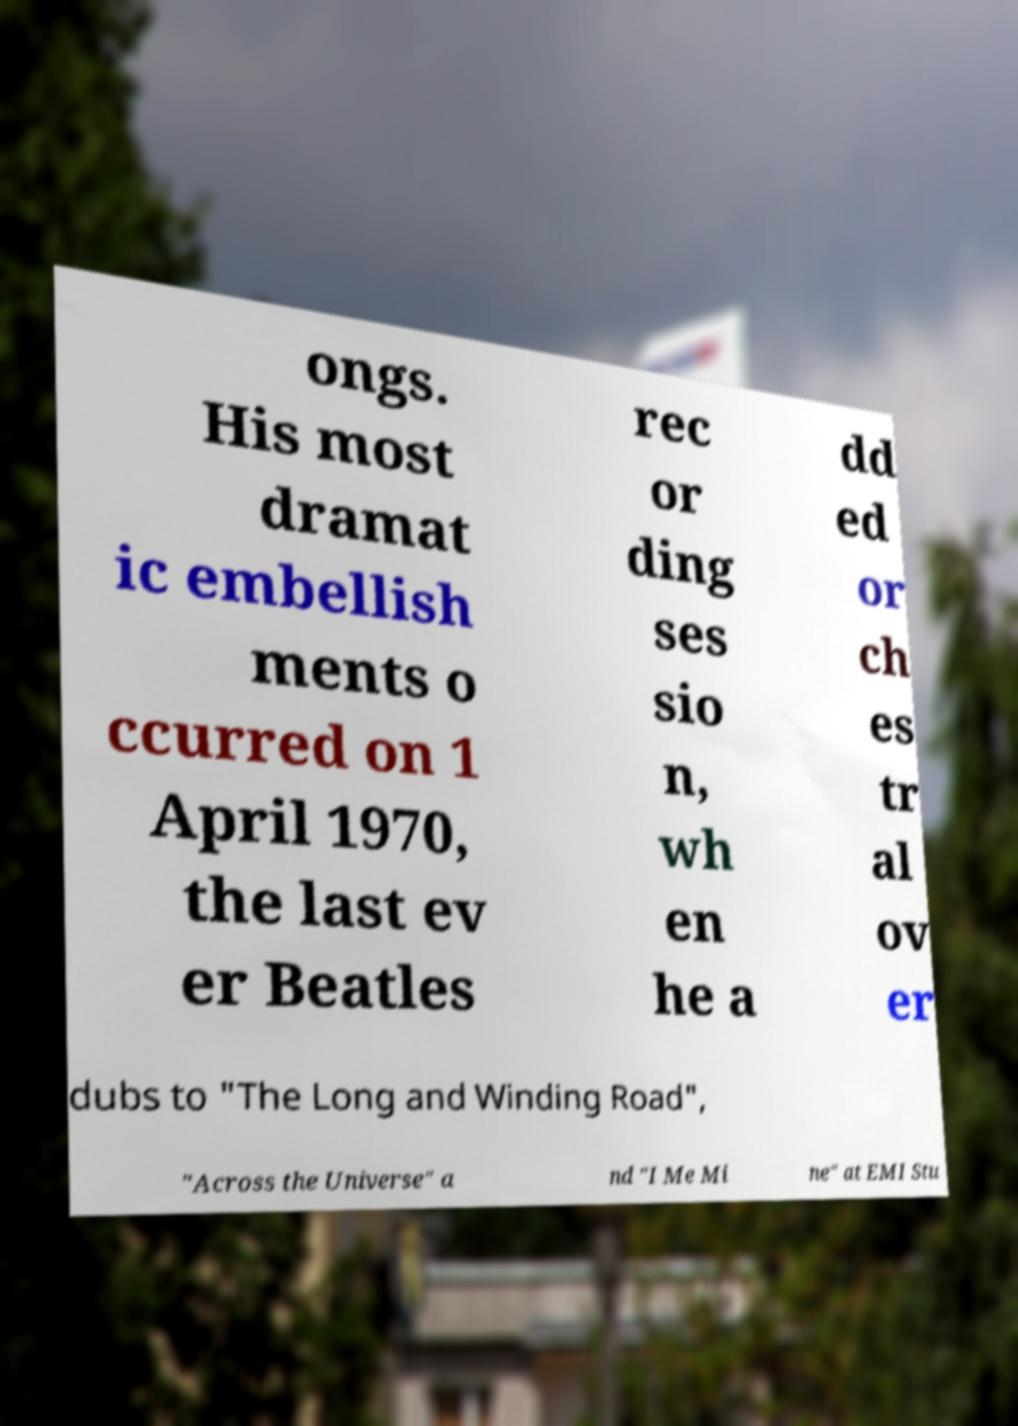There's text embedded in this image that I need extracted. Can you transcribe it verbatim? ongs. His most dramat ic embellish ments o ccurred on 1 April 1970, the last ev er Beatles rec or ding ses sio n, wh en he a dd ed or ch es tr al ov er dubs to "The Long and Winding Road", "Across the Universe" a nd "I Me Mi ne" at EMI Stu 